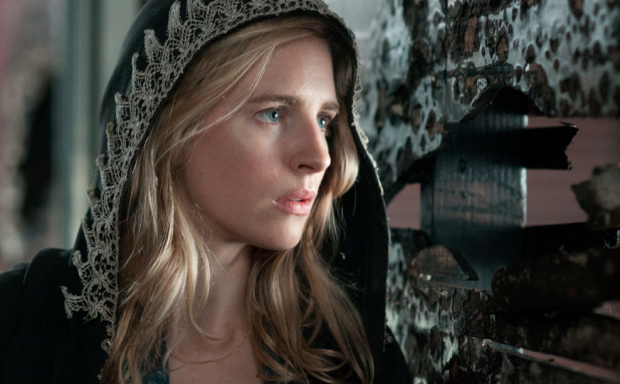Create a dialogue that might be happening offscreen. Human: 'Are you sure this is the right way?'
Character: 'Yes, the map leads us here. We just need to figure out what's hidden behind these posters.'
Human: 'I hope it’s worth the risk. We can't afford any more mistakes.'
Character: 'Trust me, we’re close. Just a little further, and we’ll find the key to everything.' What could be the significance of the posters in the background? The posters in the background might serve as remnants of a bygone era, symbols of rebellion, or messages from a resistance movement. They could hold coded information or hidden messages crucial to the character’s quest. The peeling nature of the posters suggests decay and forgotten secrets waiting to be uncovered, adding depth to the story and hinting at a larger, unseen narrative. 